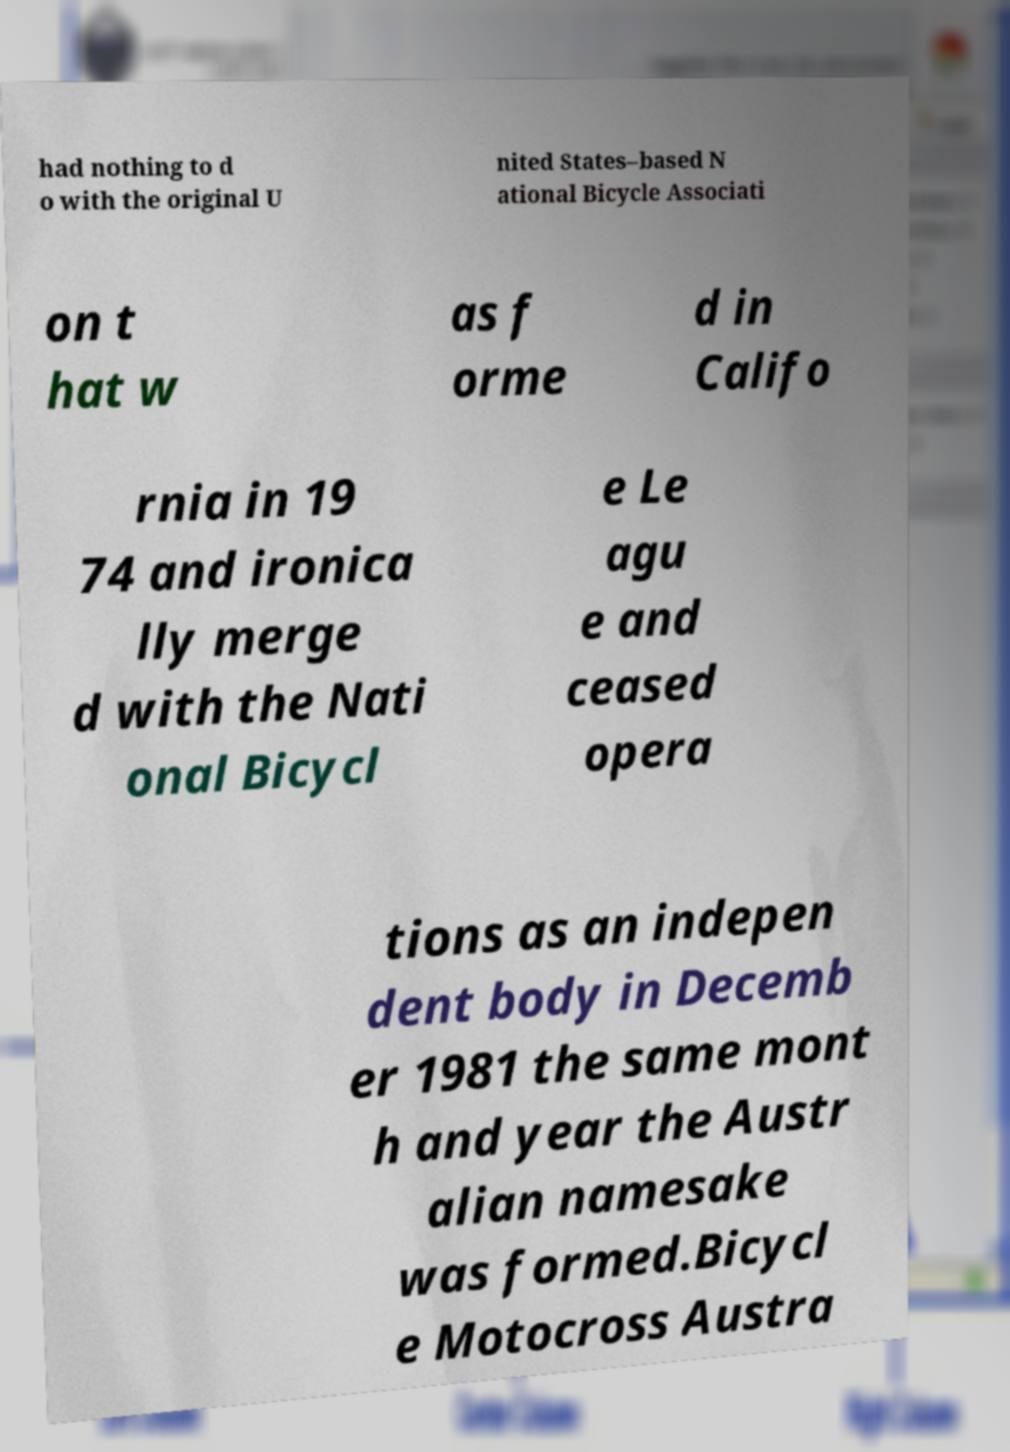For documentation purposes, I need the text within this image transcribed. Could you provide that? had nothing to d o with the original U nited States–based N ational Bicycle Associati on t hat w as f orme d in Califo rnia in 19 74 and ironica lly merge d with the Nati onal Bicycl e Le agu e and ceased opera tions as an indepen dent body in Decemb er 1981 the same mont h and year the Austr alian namesake was formed.Bicycl e Motocross Austra 